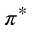Convert formula to latex. <formula><loc_0><loc_0><loc_500><loc_500>\pi ^ { * }</formula> 